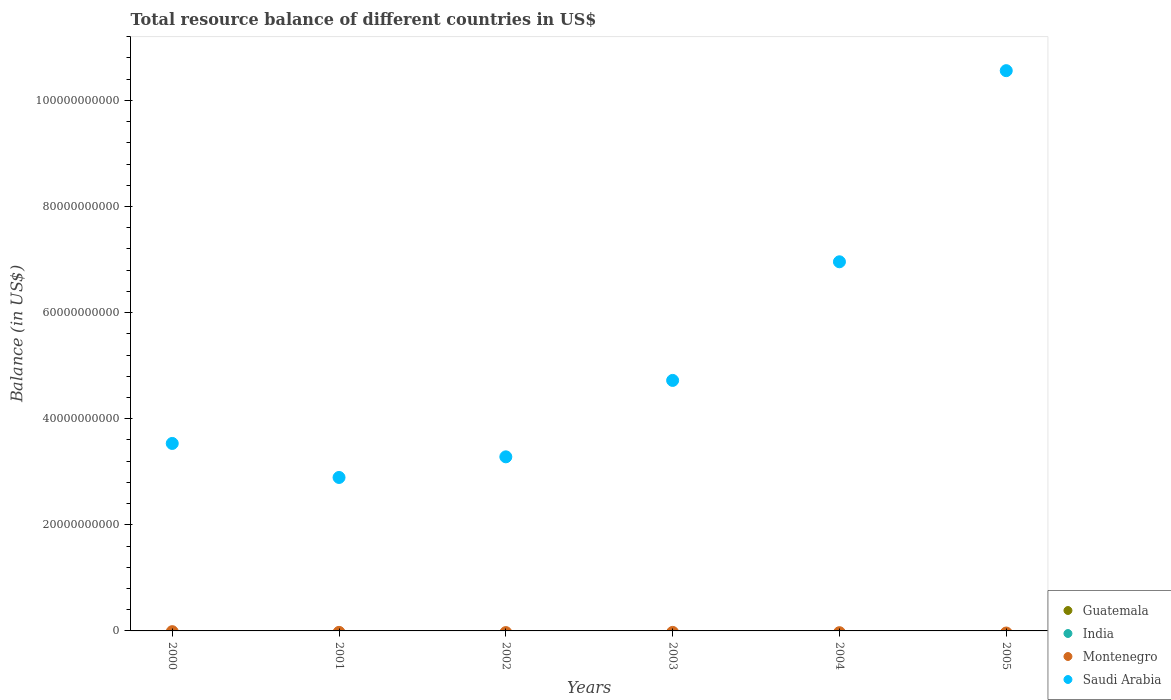Across all years, what is the maximum total resource balance in Saudi Arabia?
Provide a short and direct response. 1.06e+11. In which year was the total resource balance in Saudi Arabia maximum?
Give a very brief answer. 2005. What is the total total resource balance in India in the graph?
Provide a succinct answer. 0. What is the difference between the total resource balance in Saudi Arabia in 2001 and that in 2004?
Your answer should be very brief. -4.06e+1. What is the average total resource balance in India per year?
Offer a very short reply. 0. Is the total resource balance in Saudi Arabia in 2000 less than that in 2004?
Your answer should be compact. Yes. What is the difference between the highest and the lowest total resource balance in Saudi Arabia?
Your answer should be compact. 7.67e+1. In how many years, is the total resource balance in Montenegro greater than the average total resource balance in Montenegro taken over all years?
Your answer should be very brief. 0. Is it the case that in every year, the sum of the total resource balance in Guatemala and total resource balance in India  is greater than the sum of total resource balance in Saudi Arabia and total resource balance in Montenegro?
Give a very brief answer. No. Does the total resource balance in Montenegro monotonically increase over the years?
Make the answer very short. No. Are the values on the major ticks of Y-axis written in scientific E-notation?
Give a very brief answer. No. Does the graph contain grids?
Your answer should be compact. No. Where does the legend appear in the graph?
Offer a very short reply. Bottom right. How many legend labels are there?
Your response must be concise. 4. How are the legend labels stacked?
Provide a short and direct response. Vertical. What is the title of the graph?
Give a very brief answer. Total resource balance of different countries in US$. Does "Sao Tome and Principe" appear as one of the legend labels in the graph?
Offer a very short reply. No. What is the label or title of the Y-axis?
Provide a succinct answer. Balance (in US$). What is the Balance (in US$) in Montenegro in 2000?
Make the answer very short. 0. What is the Balance (in US$) of Saudi Arabia in 2000?
Your response must be concise. 3.53e+1. What is the Balance (in US$) in Guatemala in 2001?
Keep it short and to the point. 0. What is the Balance (in US$) of Montenegro in 2001?
Keep it short and to the point. 0. What is the Balance (in US$) in Saudi Arabia in 2001?
Provide a succinct answer. 2.89e+1. What is the Balance (in US$) in Guatemala in 2002?
Offer a very short reply. 0. What is the Balance (in US$) of Saudi Arabia in 2002?
Offer a very short reply. 3.28e+1. What is the Balance (in US$) in Montenegro in 2003?
Give a very brief answer. 0. What is the Balance (in US$) in Saudi Arabia in 2003?
Your response must be concise. 4.72e+1. What is the Balance (in US$) of Saudi Arabia in 2004?
Your answer should be very brief. 6.96e+1. What is the Balance (in US$) in Guatemala in 2005?
Your answer should be compact. 0. What is the Balance (in US$) of India in 2005?
Keep it short and to the point. 0. What is the Balance (in US$) in Montenegro in 2005?
Keep it short and to the point. 0. What is the Balance (in US$) of Saudi Arabia in 2005?
Offer a terse response. 1.06e+11. Across all years, what is the maximum Balance (in US$) of Saudi Arabia?
Keep it short and to the point. 1.06e+11. Across all years, what is the minimum Balance (in US$) of Saudi Arabia?
Your answer should be compact. 2.89e+1. What is the total Balance (in US$) in India in the graph?
Keep it short and to the point. 0. What is the total Balance (in US$) of Saudi Arabia in the graph?
Your answer should be compact. 3.19e+11. What is the difference between the Balance (in US$) in Saudi Arabia in 2000 and that in 2001?
Provide a short and direct response. 6.41e+09. What is the difference between the Balance (in US$) in Saudi Arabia in 2000 and that in 2002?
Keep it short and to the point. 2.52e+09. What is the difference between the Balance (in US$) in Saudi Arabia in 2000 and that in 2003?
Your answer should be compact. -1.19e+1. What is the difference between the Balance (in US$) in Saudi Arabia in 2000 and that in 2004?
Keep it short and to the point. -3.42e+1. What is the difference between the Balance (in US$) of Saudi Arabia in 2000 and that in 2005?
Ensure brevity in your answer.  -7.03e+1. What is the difference between the Balance (in US$) of Saudi Arabia in 2001 and that in 2002?
Ensure brevity in your answer.  -3.89e+09. What is the difference between the Balance (in US$) in Saudi Arabia in 2001 and that in 2003?
Ensure brevity in your answer.  -1.83e+1. What is the difference between the Balance (in US$) in Saudi Arabia in 2001 and that in 2004?
Keep it short and to the point. -4.06e+1. What is the difference between the Balance (in US$) of Saudi Arabia in 2001 and that in 2005?
Offer a very short reply. -7.67e+1. What is the difference between the Balance (in US$) in Saudi Arabia in 2002 and that in 2003?
Your answer should be compact. -1.44e+1. What is the difference between the Balance (in US$) in Saudi Arabia in 2002 and that in 2004?
Offer a very short reply. -3.68e+1. What is the difference between the Balance (in US$) of Saudi Arabia in 2002 and that in 2005?
Your answer should be very brief. -7.28e+1. What is the difference between the Balance (in US$) in Saudi Arabia in 2003 and that in 2004?
Ensure brevity in your answer.  -2.24e+1. What is the difference between the Balance (in US$) in Saudi Arabia in 2003 and that in 2005?
Offer a terse response. -5.84e+1. What is the difference between the Balance (in US$) of Saudi Arabia in 2004 and that in 2005?
Offer a very short reply. -3.60e+1. What is the average Balance (in US$) in Guatemala per year?
Provide a short and direct response. 0. What is the average Balance (in US$) in Montenegro per year?
Make the answer very short. 0. What is the average Balance (in US$) in Saudi Arabia per year?
Give a very brief answer. 5.32e+1. What is the ratio of the Balance (in US$) of Saudi Arabia in 2000 to that in 2001?
Offer a very short reply. 1.22. What is the ratio of the Balance (in US$) in Saudi Arabia in 2000 to that in 2003?
Make the answer very short. 0.75. What is the ratio of the Balance (in US$) of Saudi Arabia in 2000 to that in 2004?
Offer a very short reply. 0.51. What is the ratio of the Balance (in US$) of Saudi Arabia in 2000 to that in 2005?
Keep it short and to the point. 0.33. What is the ratio of the Balance (in US$) in Saudi Arabia in 2001 to that in 2002?
Your answer should be very brief. 0.88. What is the ratio of the Balance (in US$) in Saudi Arabia in 2001 to that in 2003?
Your answer should be compact. 0.61. What is the ratio of the Balance (in US$) of Saudi Arabia in 2001 to that in 2004?
Offer a terse response. 0.42. What is the ratio of the Balance (in US$) in Saudi Arabia in 2001 to that in 2005?
Provide a succinct answer. 0.27. What is the ratio of the Balance (in US$) of Saudi Arabia in 2002 to that in 2003?
Provide a succinct answer. 0.69. What is the ratio of the Balance (in US$) of Saudi Arabia in 2002 to that in 2004?
Make the answer very short. 0.47. What is the ratio of the Balance (in US$) in Saudi Arabia in 2002 to that in 2005?
Your answer should be compact. 0.31. What is the ratio of the Balance (in US$) of Saudi Arabia in 2003 to that in 2004?
Give a very brief answer. 0.68. What is the ratio of the Balance (in US$) in Saudi Arabia in 2003 to that in 2005?
Provide a short and direct response. 0.45. What is the ratio of the Balance (in US$) in Saudi Arabia in 2004 to that in 2005?
Your answer should be compact. 0.66. What is the difference between the highest and the second highest Balance (in US$) of Saudi Arabia?
Provide a short and direct response. 3.60e+1. What is the difference between the highest and the lowest Balance (in US$) of Saudi Arabia?
Make the answer very short. 7.67e+1. 